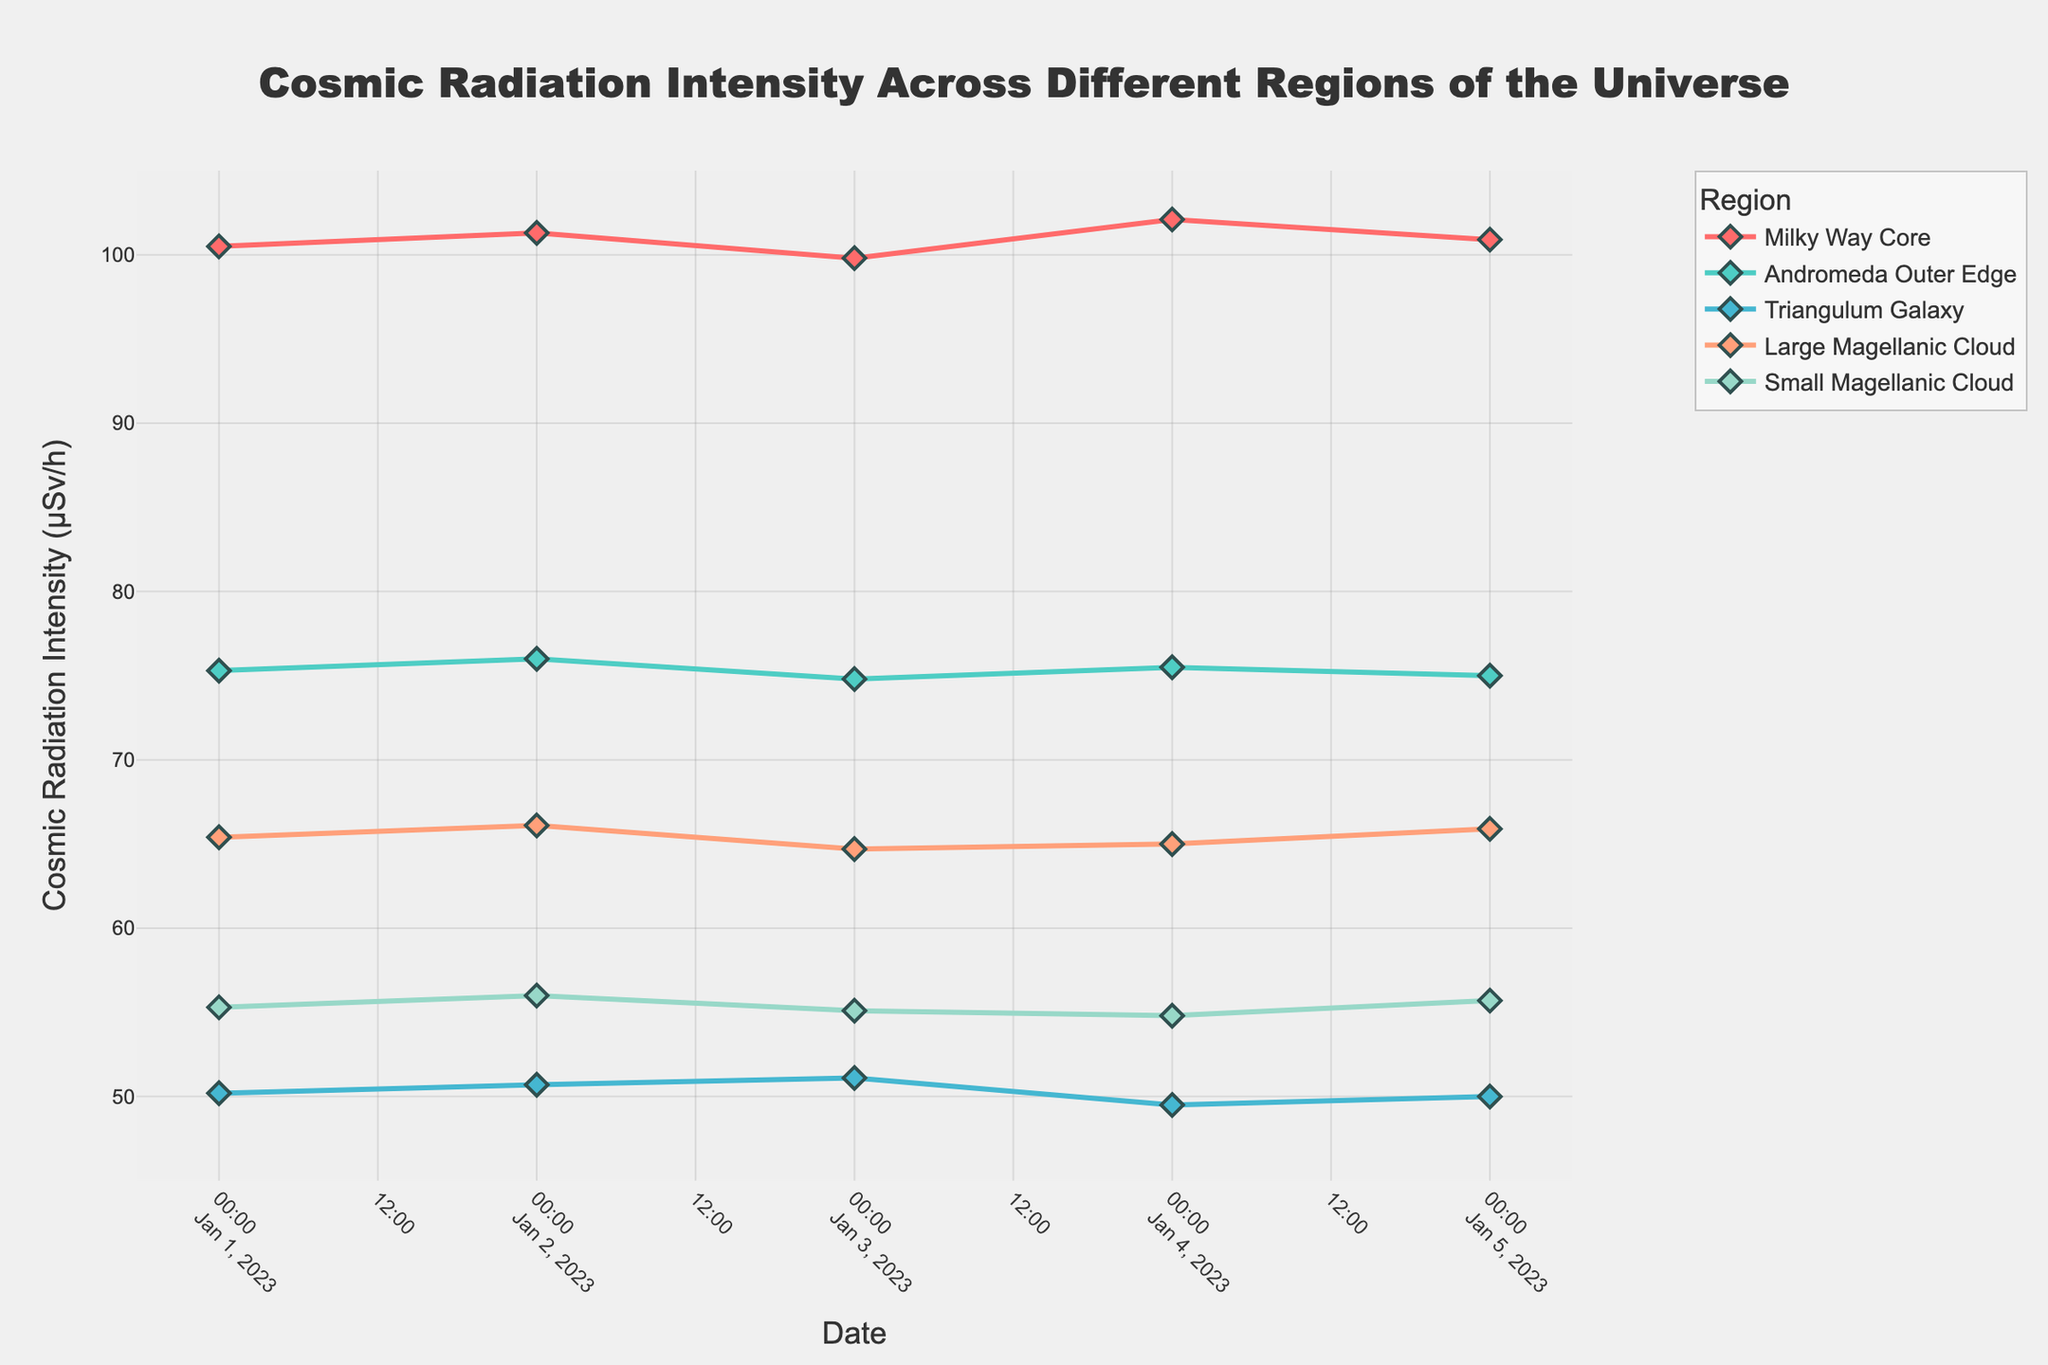What's the title of the figure? The title is the text usually located at the top of the figure. For this plot, the title is given as "Cosmic Radiation Intensity Across Different Regions of the Universe"
Answer: Cosmic Radiation Intensity Across Different Regions of the Universe Which region has the highest average cosmic radiation intensity? To find this, we calculate the average cosmic radiation intensity for each region based on the provided data points and compare them. The Milky Way Core has the highest average at an approximately 100.92 µSv/h.
Answer: Milky Way Core How does the trend of cosmic radiation intensity in the Milky Way Core change over the five observed days? By observing the time series plot for the Milky Way Core, it starts at 100.5 µSv/h, slightly increases to 101.3 µSv/h on the next day, decreases to 99.8 µSv/h, increases again to 102.1 µSv/h, and finally slightly decreases to 100.9 µSv/h.
Answer: It fluctuates with slight increases and decreases On which date does the triangulum Galaxy have the maximum cosmic radiation intensity, and what's the value? Check the plot for the Triangulum Galaxy and note the peak value, which is on 2023-01-03 with a value of 51.1 µSv/h.
Answer: 2023-01-03, 51.1 µSv/h Which region shows the least variation in cosmic radiation intensity over the observed period? This can be found by visually inspecting the range of fluctuation for each region. The Andromeda Outer Edge experiences the least variation with values ranging from 74.8 to 76.0 µSv/h.
Answer: Andromeda Outer Edge Compare the cosmic radiation intensity trends in the Large and Small Magellanic Clouds. How are they similar or different? Both regions show slight fluctuations over the period. The Large Magellanic Cloud starts higher but shows a dip and rise similar to the Small Magellanic Cloud. The Small Magellanic Cloud also fluctuates slightly but ends close to its starting value.
Answer: Both have slight fluctuations; the Large Magellanic Cloud is a bit higher overall Which region has the highest variability in cosmic radiation intensity, and what is the range of this variability? By examining the plot, the Milky Way Core region has the highest variability with values ranging from 99.8 to 102.1 µSv/h.
Answer: Milky Way Core, 99.8 to 102.1 µSv/h What is the cosmic radiation intensity in the Small Magellanic Cloud on 2023-01-03? Refer to the Small Magellanic Cloud data points on the plot. On 2023-01-03, the value is 55.1 µSv/h.
Answer: 55.1 µSv/h How much higher is the average cosmic radiation intensity in the Milky Way Core compared to the Triangulum Galaxy? First, calculate the average intensity for both regions: Milky Way Core (~100.92 µSv/h) and Triangulum Galaxy (~50.3 µSv/h). The average difference is 100.92 - 50.3 = 50.62 µSv/h.
Answer: 50.62 µSv/h 